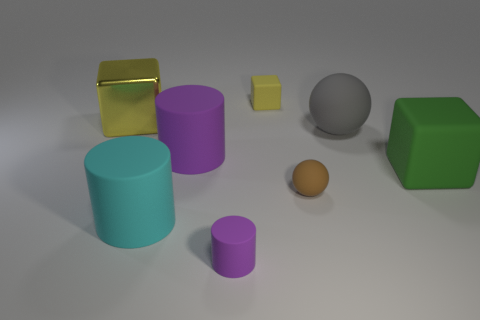Subtract all small rubber cylinders. How many cylinders are left? 2 Subtract all balls. How many objects are left? 6 Subtract all green cubes. How many cubes are left? 2 Subtract 2 cylinders. How many cylinders are left? 1 Add 1 tiny blue metallic blocks. How many objects exist? 9 Subtract all green balls. How many green blocks are left? 1 Subtract all small cyan metal things. Subtract all rubber cylinders. How many objects are left? 5 Add 4 large green objects. How many large green objects are left? 5 Add 4 big yellow things. How many big yellow things exist? 5 Subtract 1 yellow cubes. How many objects are left? 7 